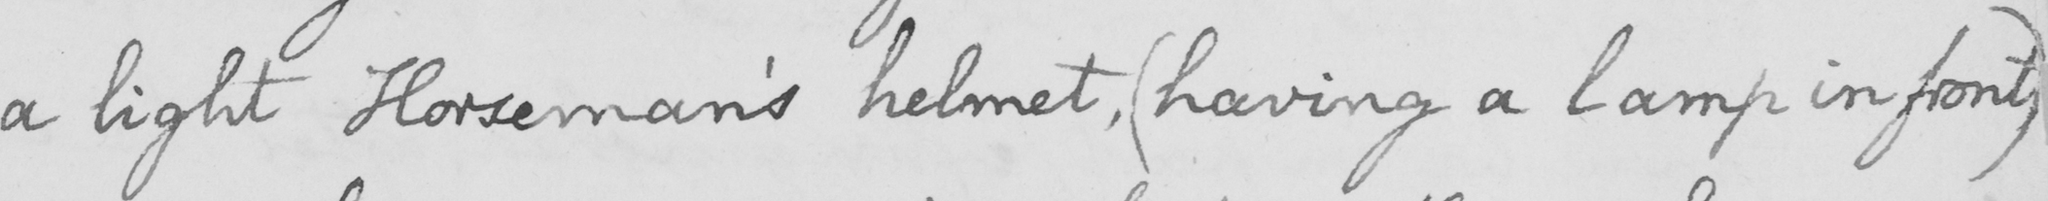Transcribe the text shown in this historical manuscript line. a light Horseman ' s helmet ,  ( having a lamp in front ) 